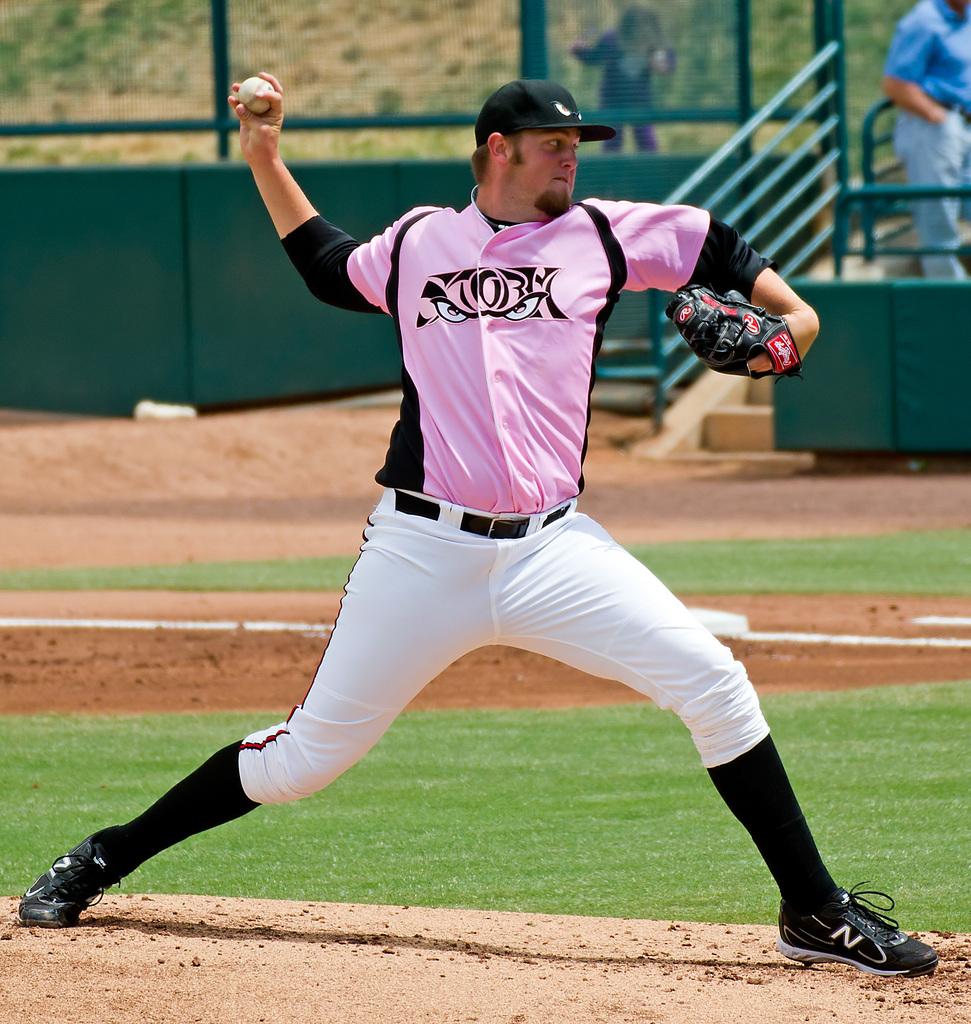What letter is on his shoes?
Your answer should be compact. N. 